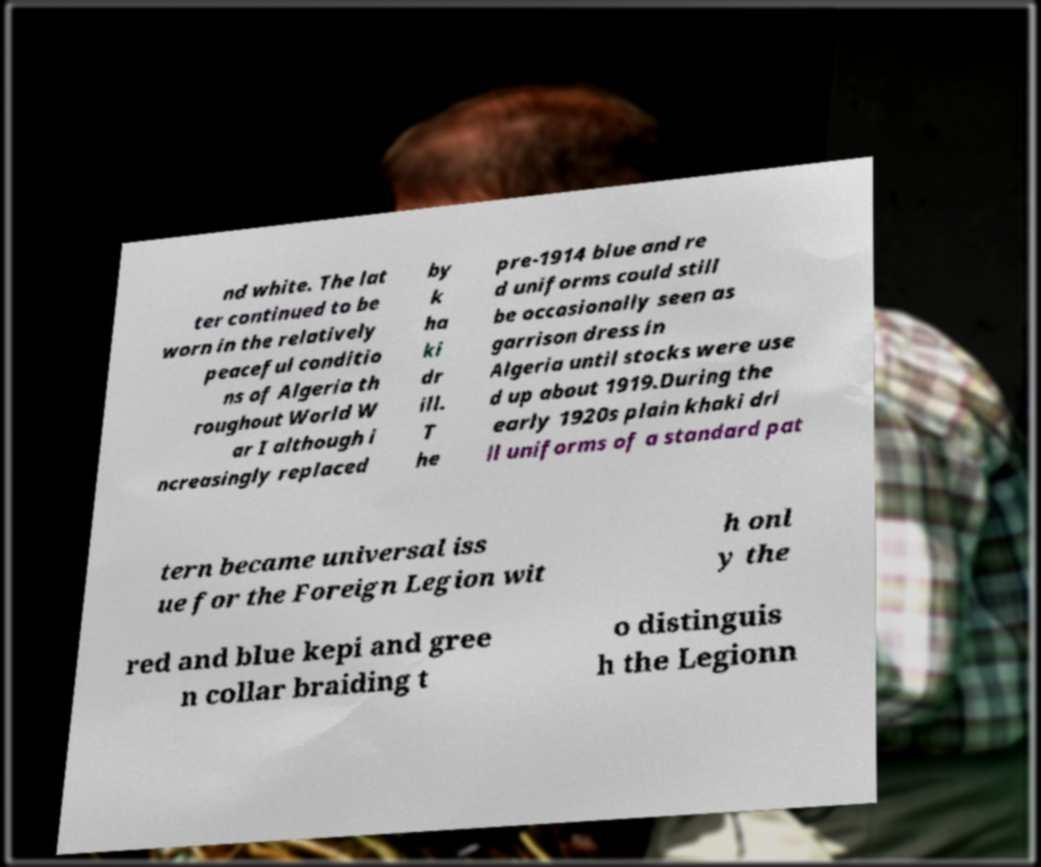Can you accurately transcribe the text from the provided image for me? nd white. The lat ter continued to be worn in the relatively peaceful conditio ns of Algeria th roughout World W ar I although i ncreasingly replaced by k ha ki dr ill. T he pre-1914 blue and re d uniforms could still be occasionally seen as garrison dress in Algeria until stocks were use d up about 1919.During the early 1920s plain khaki dri ll uniforms of a standard pat tern became universal iss ue for the Foreign Legion wit h onl y the red and blue kepi and gree n collar braiding t o distinguis h the Legionn 